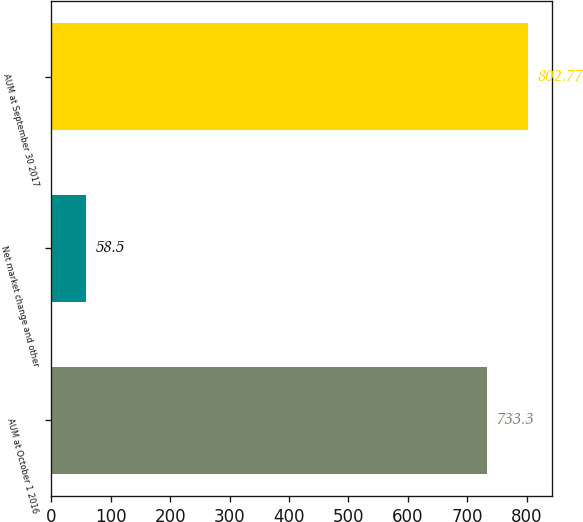Convert chart. <chart><loc_0><loc_0><loc_500><loc_500><bar_chart><fcel>AUM at October 1 2016<fcel>Net market change and other<fcel>AUM at September 30 2017<nl><fcel>733.3<fcel>58.5<fcel>802.77<nl></chart> 